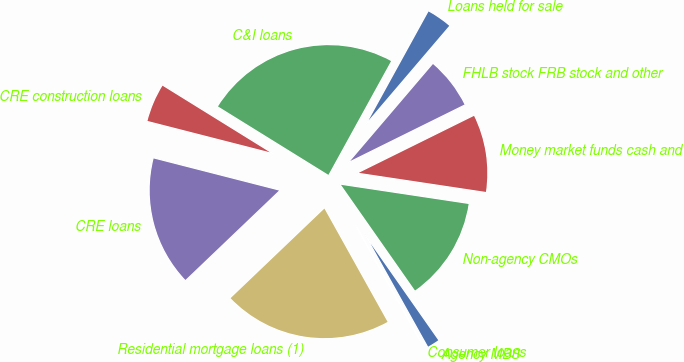<chart> <loc_0><loc_0><loc_500><loc_500><pie_chart><fcel>Loans held for sale<fcel>C&I loans<fcel>CRE construction loans<fcel>CRE loans<fcel>Residential mortgage loans (1)<fcel>Consumer loans<fcel>Agency MBS<fcel>Non-agency CMOs<fcel>Money market funds cash and<fcel>FHLB stock FRB stock and other<nl><fcel>3.23%<fcel>24.18%<fcel>4.84%<fcel>16.12%<fcel>20.96%<fcel>0.01%<fcel>1.62%<fcel>12.9%<fcel>9.68%<fcel>6.45%<nl></chart> 